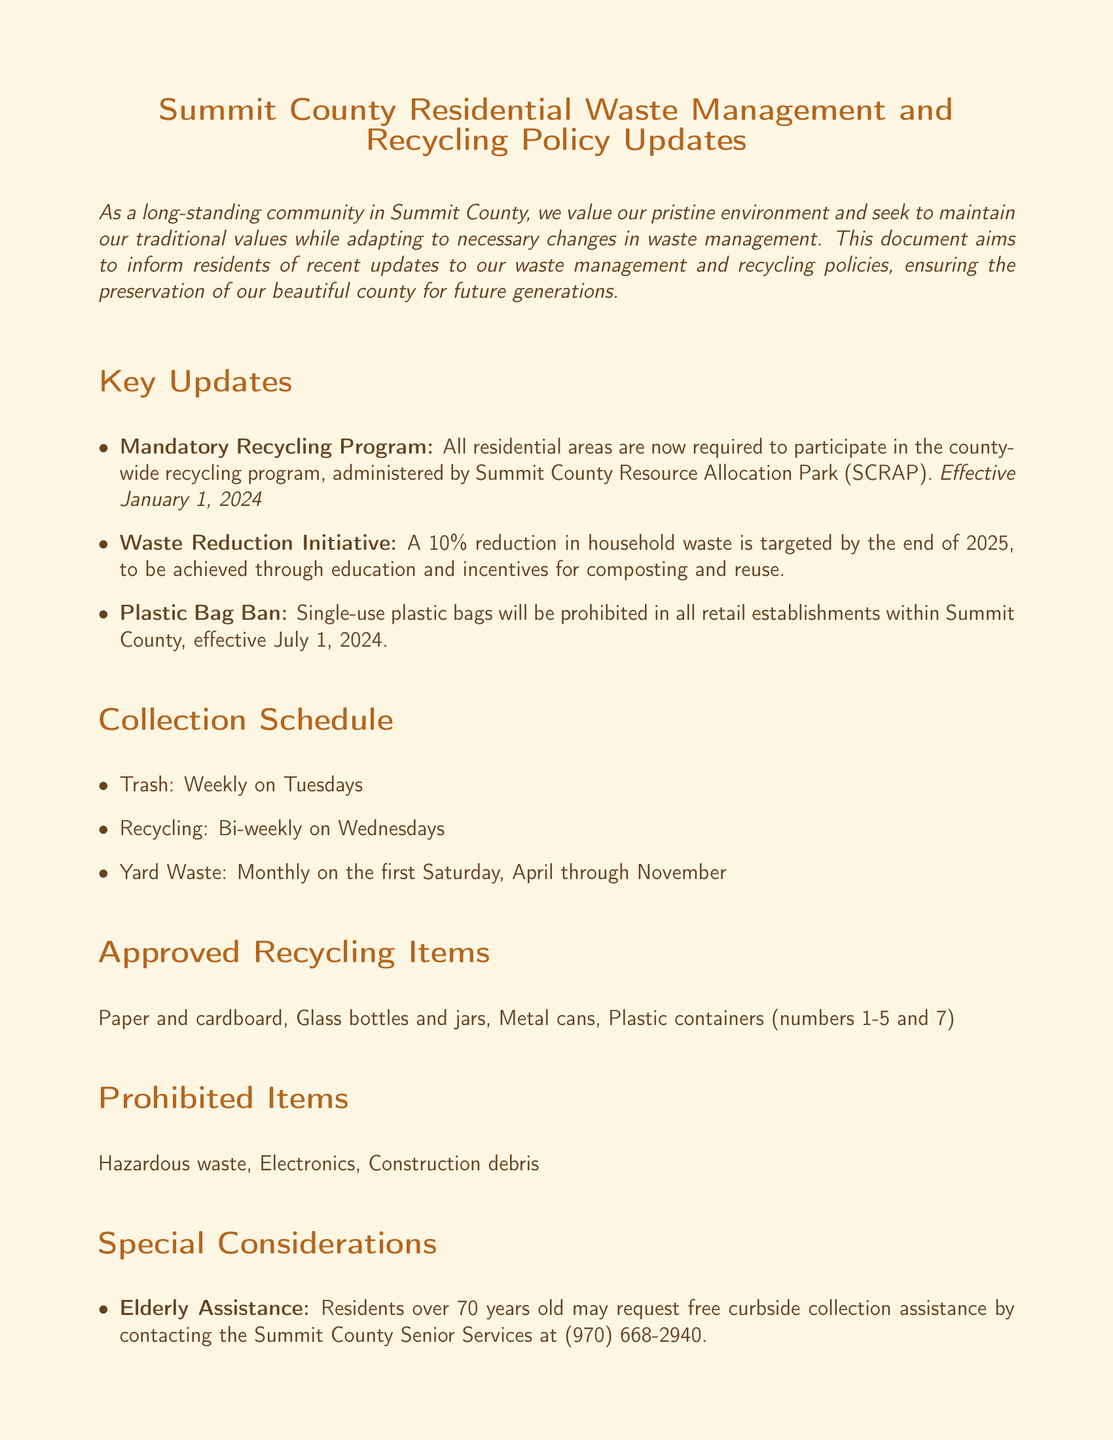What is the effective date for the mandatory recycling program? The effective date for the mandatory recycling program is specified in the document and is set for January 1, 2024.
Answer: January 1, 2024 How often will yard waste be collected? The document states that yard waste will be collected monthly on the first Saturday, from April through November.
Answer: Monthly on the first Saturday What is the target reduction percentage for household waste by the end of 2025? The document mentions a target of a specific percentage reduction in household waste, which is 10%.
Answer: 10% Who can request free curbside collection assistance? According to the document, residents over a certain age, specifically 70 years old, can request this assistance.
Answer: Residents over 70 Which items are prohibited for recycling? The document lists specific items that are not accepted for recycling, including hazardous waste and electronics.
Answer: Hazardous waste, Electronics What types of containers must be used in residential areas bordering national forest lands? The document indicates that bear-proof containers are required in these residential areas for trash storage.
Answer: Bear-proof containers When is the recycling collection scheduled? The timing for recycling collection is detailed in the document, stating that it occurs bi-weekly.
Answer: Bi-weekly on Wednesdays What organization administers the recycling program? The document specifies that the program is run by a specific organization, namely Summit County Resource Allocation Park (SCRAP).
Answer: Summit County Resource Allocation Park (SCRAP) What item numbers are accepted for plastic containers in recycling? The document outlines the acceptable plastic container numbers for recycling, which are listed as numbers 1-5 and 7.
Answer: Numbers 1-5 and 7 